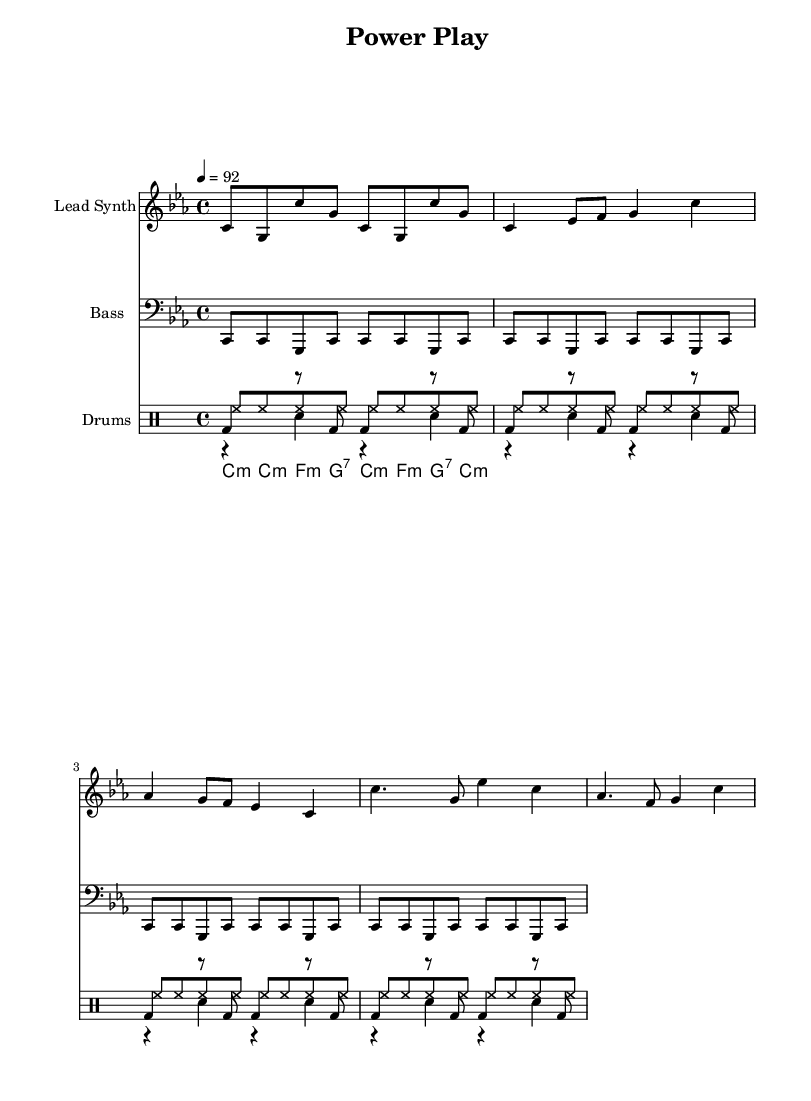What is the key signature of this music? The key signature is C minor, which has three flats (B♭, E♭, A♭). This can be confirmed by observing the key signature indicated at the beginning of the score.
Answer: C minor What is the time signature of this music? The time signature displayed at the beginning of the score is 4/4, meaning there are four beats in each measure and the quarter note receives one beat. This is indicated by the "4/4" notation.
Answer: 4/4 What is the tempo marking? The tempo marking indicates that the music should be played at a speed of 92 beats per minute as shown next to the tempo indication. This number defines how fast the piece should be played.
Answer: 92 How many verses are included in the lead synth section? The lead synth section has one full verse, which can be recognized by analyzing the repetition of the musical phrases that correspond to the structure typical of verses in hip hop. There’s no indication of repeating verses.
Answer: One What drums are used in this composition? The composition features three types of drums: kick drum, snare drum, and hi-hat, as can be seen by examining the drum parts listed in the score. Each type of drum is represented in separate voices under the DrumStaff notation.
Answer: Kick, snare, hi-hat What is the structure type of this piece? The piece follows a common hip hop structure of verses and choruses that is reflected in the provided sections of lead synth, where specific patterns are repeated, indicating the presence of a chorus followed by verses.
Answer: Verse-Chorus 